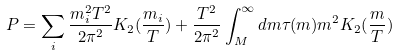Convert formula to latex. <formula><loc_0><loc_0><loc_500><loc_500>P = \sum _ { i } { \frac { m _ { i } ^ { 2 } T ^ { 2 } } { 2 \pi ^ { 2 } } } K _ { 2 } ( { \frac { m _ { i } } { T } } ) + { \frac { T ^ { 2 } } { 2 \pi ^ { 2 } } } \int _ { M } ^ { \infty } d m \tau ( m ) m ^ { 2 } K _ { 2 } ( { \frac { m } { T } } )</formula> 